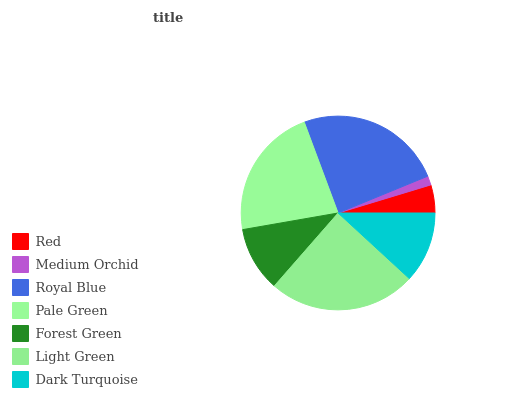Is Medium Orchid the minimum?
Answer yes or no. Yes. Is Light Green the maximum?
Answer yes or no. Yes. Is Royal Blue the minimum?
Answer yes or no. No. Is Royal Blue the maximum?
Answer yes or no. No. Is Royal Blue greater than Medium Orchid?
Answer yes or no. Yes. Is Medium Orchid less than Royal Blue?
Answer yes or no. Yes. Is Medium Orchid greater than Royal Blue?
Answer yes or no. No. Is Royal Blue less than Medium Orchid?
Answer yes or no. No. Is Dark Turquoise the high median?
Answer yes or no. Yes. Is Dark Turquoise the low median?
Answer yes or no. Yes. Is Forest Green the high median?
Answer yes or no. No. Is Light Green the low median?
Answer yes or no. No. 